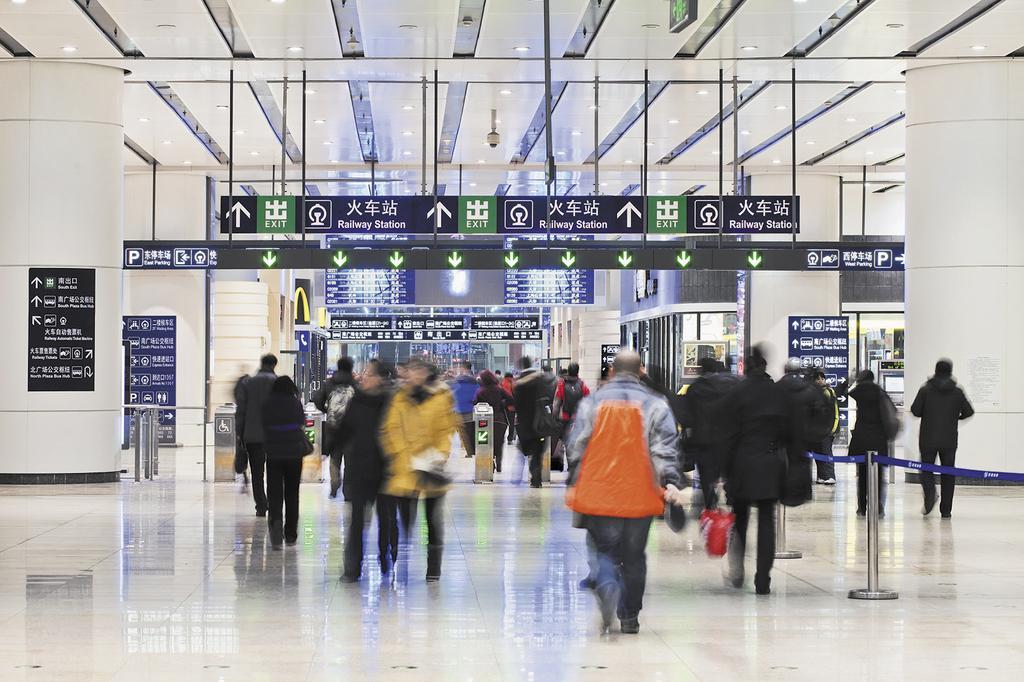Describe this image in one or two sentences. In this picture there is a inside view of the railway station lobby. In the front there are many people walking in the front. Above there are many hanging and direction boards. On both the side there are some white pillars. 